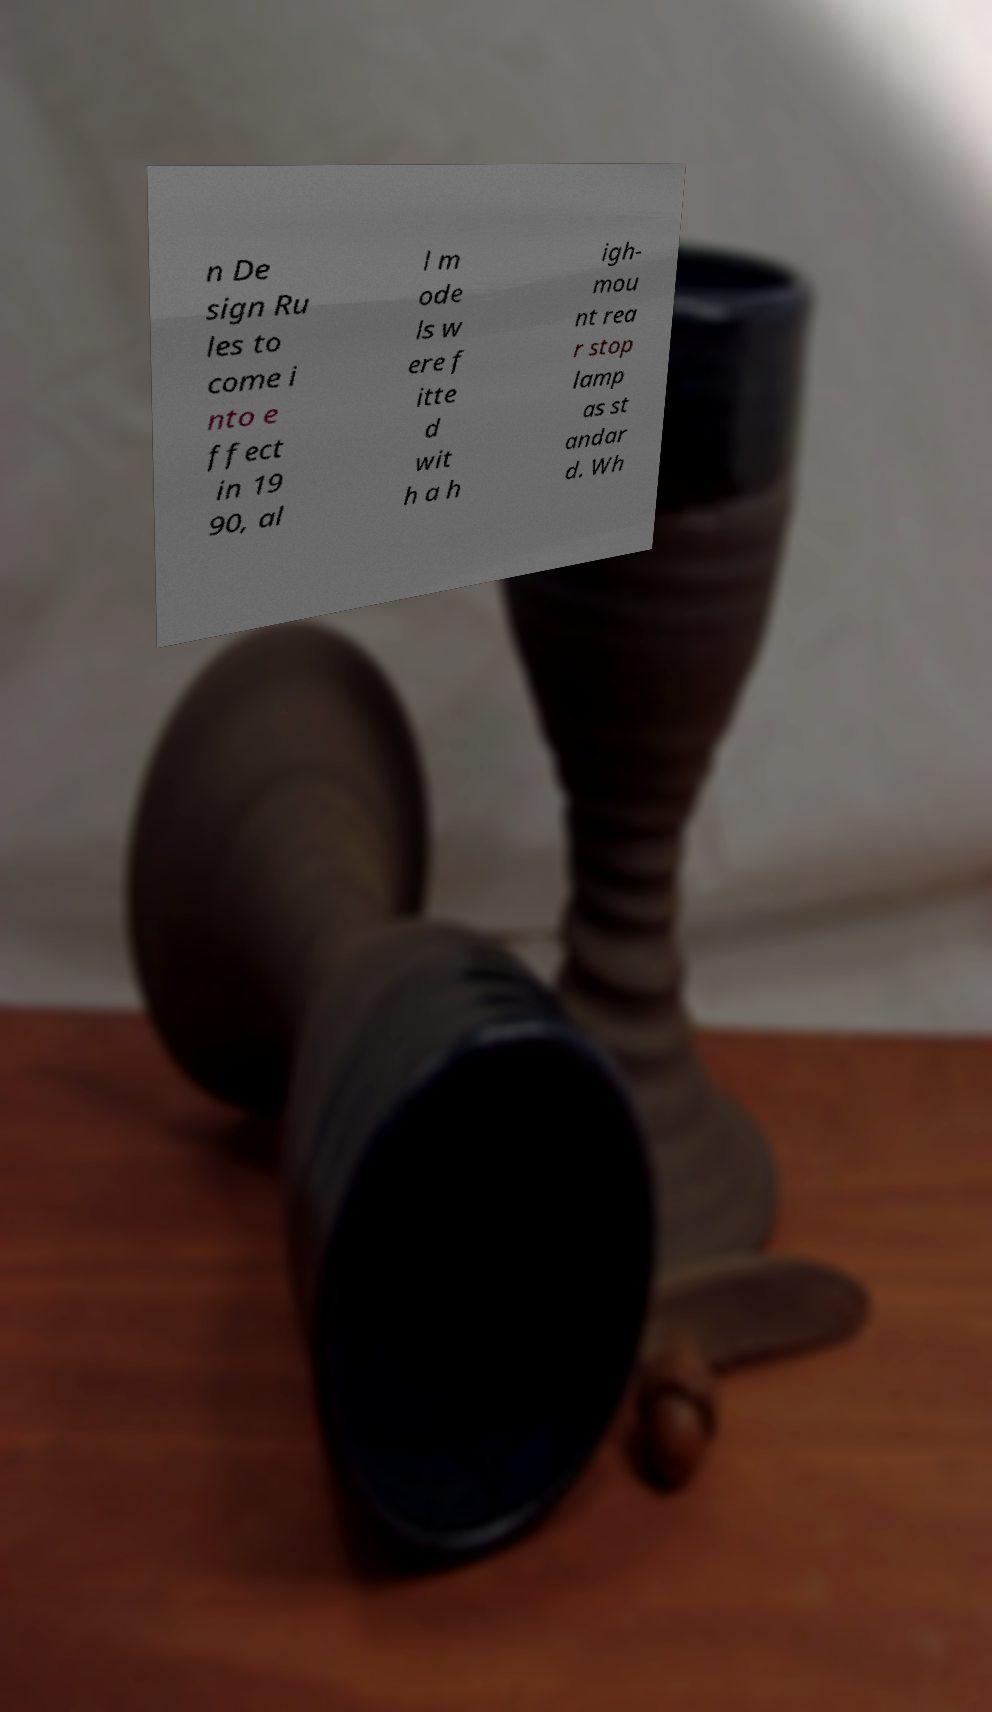Please identify and transcribe the text found in this image. n De sign Ru les to come i nto e ffect in 19 90, al l m ode ls w ere f itte d wit h a h igh- mou nt rea r stop lamp as st andar d. Wh 